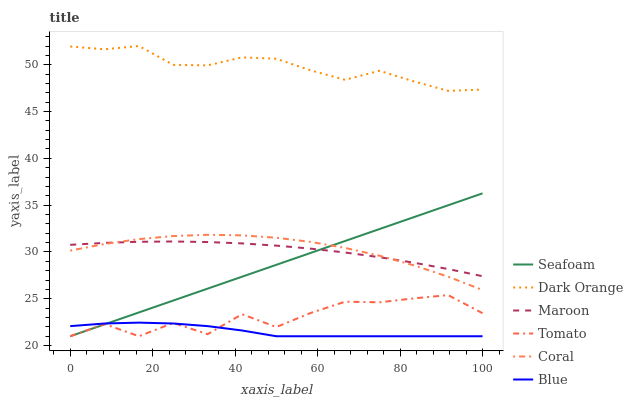Does Blue have the minimum area under the curve?
Answer yes or no. Yes. Does Dark Orange have the maximum area under the curve?
Answer yes or no. Yes. Does Coral have the minimum area under the curve?
Answer yes or no. No. Does Coral have the maximum area under the curve?
Answer yes or no. No. Is Seafoam the smoothest?
Answer yes or no. Yes. Is Tomato the roughest?
Answer yes or no. Yes. Is Dark Orange the smoothest?
Answer yes or no. No. Is Dark Orange the roughest?
Answer yes or no. No. Does Tomato have the lowest value?
Answer yes or no. Yes. Does Coral have the lowest value?
Answer yes or no. No. Does Dark Orange have the highest value?
Answer yes or no. Yes. Does Coral have the highest value?
Answer yes or no. No. Is Blue less than Maroon?
Answer yes or no. Yes. Is Dark Orange greater than Seafoam?
Answer yes or no. Yes. Does Seafoam intersect Coral?
Answer yes or no. Yes. Is Seafoam less than Coral?
Answer yes or no. No. Is Seafoam greater than Coral?
Answer yes or no. No. Does Blue intersect Maroon?
Answer yes or no. No. 